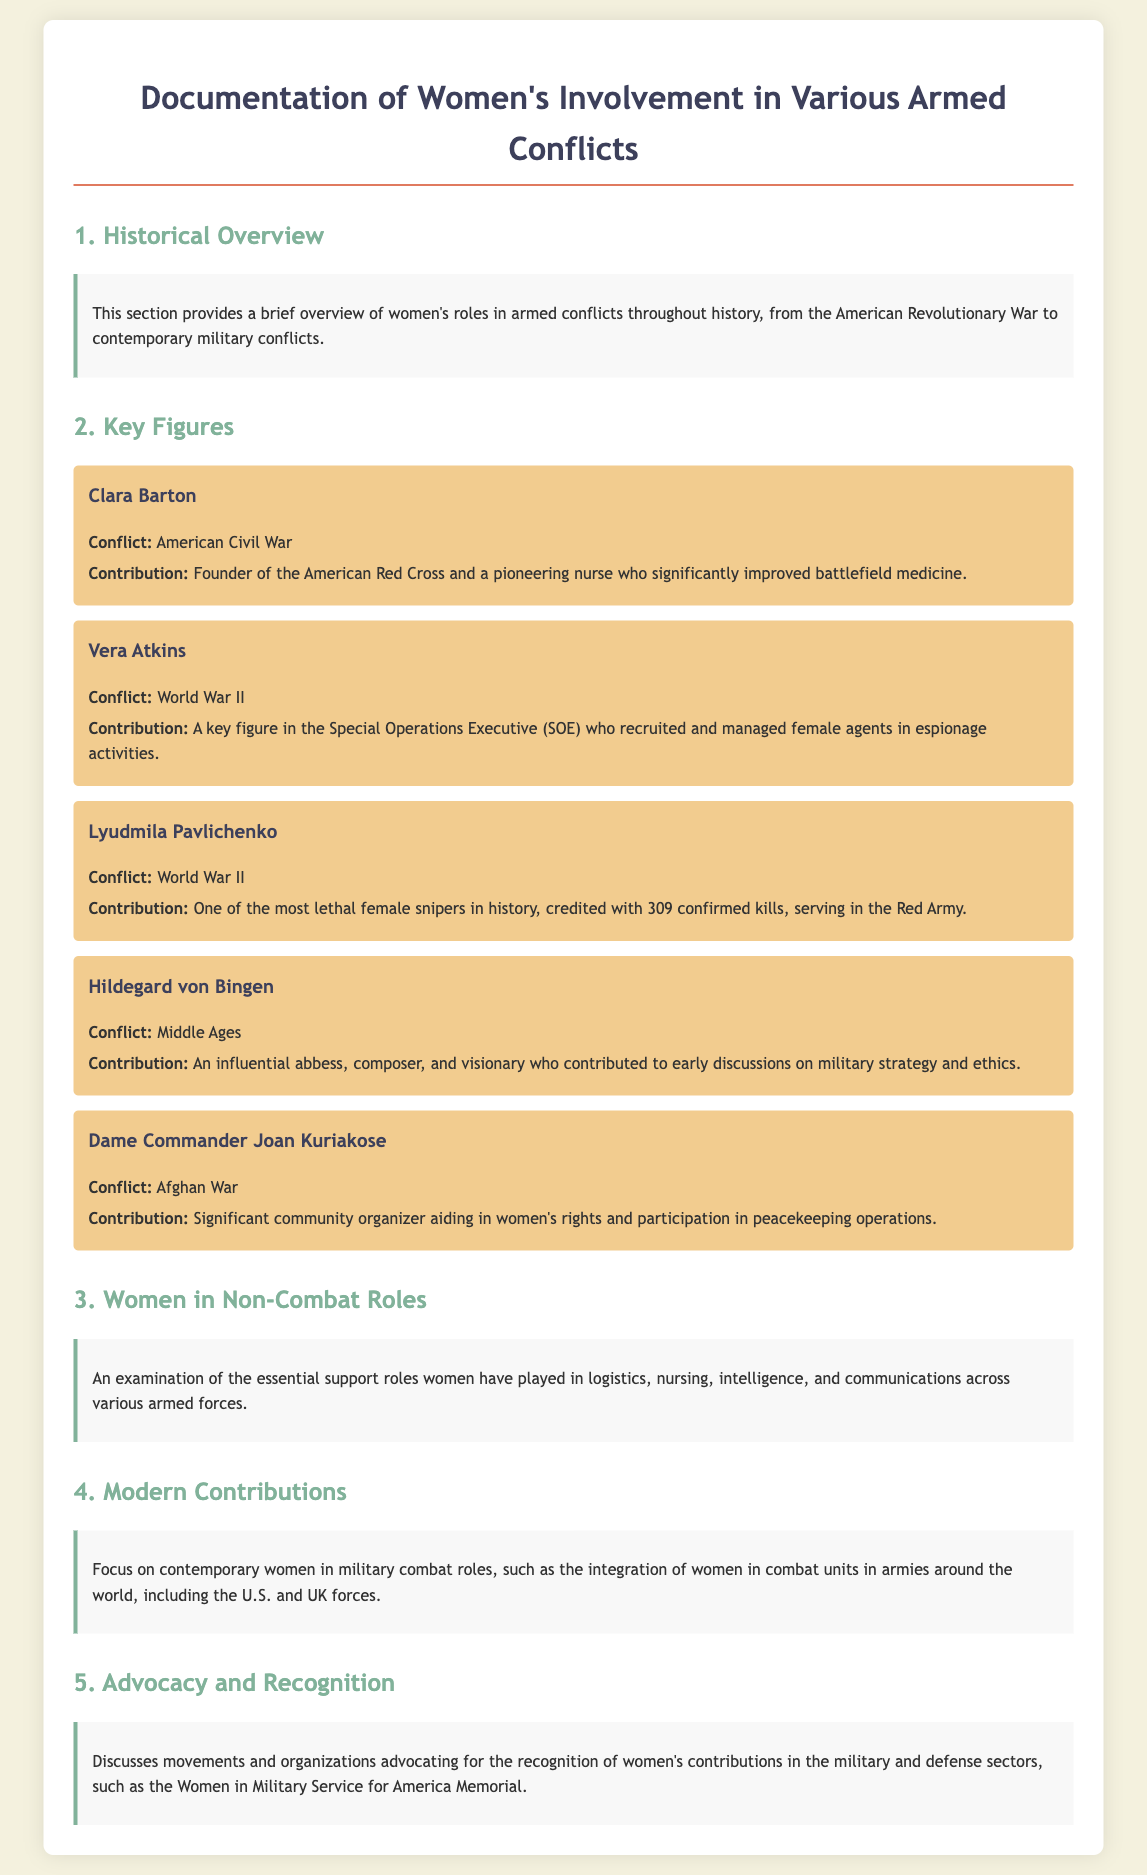What is the title of the document? The title is specified in the <title> tag of the document, which reads "Women in Armed Conflicts."
Answer: Women in Armed Conflicts Who founded the American Red Cross? Clara Barton is mentioned as the founder of the American Red Cross in the "Key Figures" section.
Answer: Clara Barton In which conflict did Vera Atkins serve? Vera Atkins is associated with World War II, as stated in the document.
Answer: World War II How many confirmed kills did Lyudmila Pavlichenko have? The document states that Lyudmila Pavlichenko is credited with 309 confirmed kills.
Answer: 309 What role did Hildegard von Bingen have in military discussions? The document describes her contribution to early discussions on military strategy and ethics.
Answer: Military strategy and ethics What is the focus of section 4? The focus of section 4 is on contemporary women in military combat roles.
Answer: Contemporary women in military combat roles Which organization advocates for women's recognition in military service? The document mentions the Women in Military Service for America Memorial as an organization that advocates for recognition.
Answer: Women in Military Service for America Memorial What is the main contribution of Dame Commander Joan Kuriakose? She is recognized as a significant community organizer aiding in women's rights and participation in peacekeeping operations.
Answer: Community organizer aiding in women's rights 